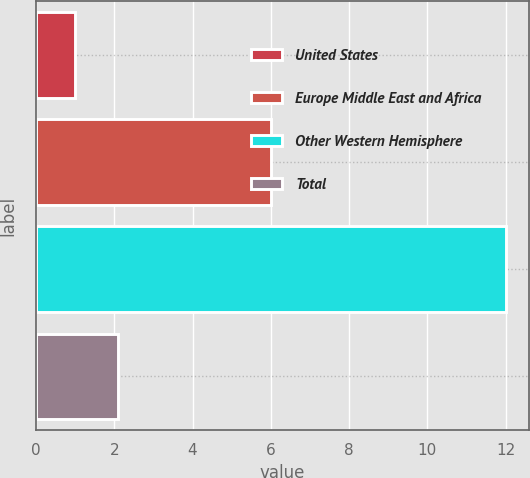Convert chart to OTSL. <chart><loc_0><loc_0><loc_500><loc_500><bar_chart><fcel>United States<fcel>Europe Middle East and Africa<fcel>Other Western Hemisphere<fcel>Total<nl><fcel>1<fcel>6<fcel>12<fcel>2.1<nl></chart> 